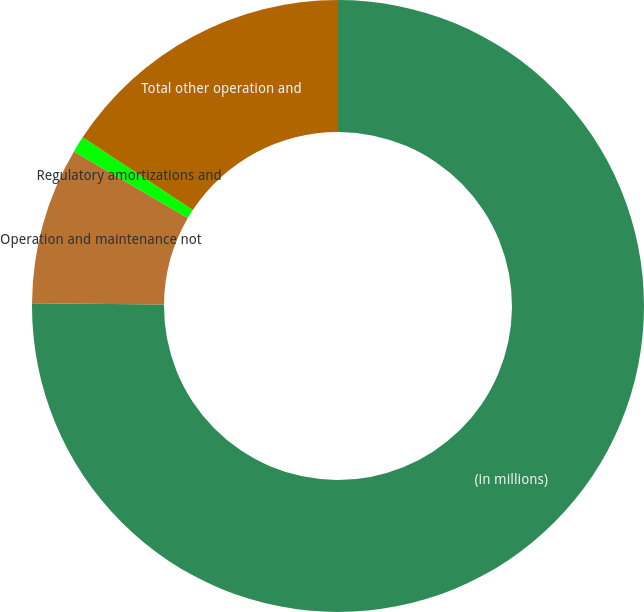<chart> <loc_0><loc_0><loc_500><loc_500><pie_chart><fcel>(in millions)<fcel>Operation and maintenance not<fcel>Regulatory amortizations and<fcel>Total other operation and<nl><fcel>75.14%<fcel>8.29%<fcel>0.86%<fcel>15.71%<nl></chart> 